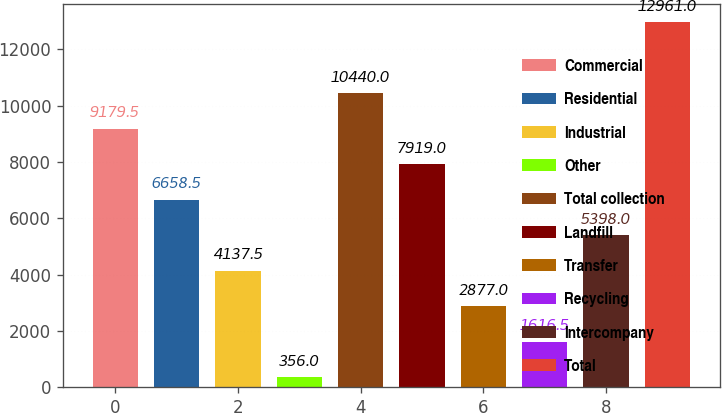Convert chart to OTSL. <chart><loc_0><loc_0><loc_500><loc_500><bar_chart><fcel>Commercial<fcel>Residential<fcel>Industrial<fcel>Other<fcel>Total collection<fcel>Landfill<fcel>Transfer<fcel>Recycling<fcel>Intercompany<fcel>Total<nl><fcel>9179.5<fcel>6658.5<fcel>4137.5<fcel>356<fcel>10440<fcel>7919<fcel>2877<fcel>1616.5<fcel>5398<fcel>12961<nl></chart> 